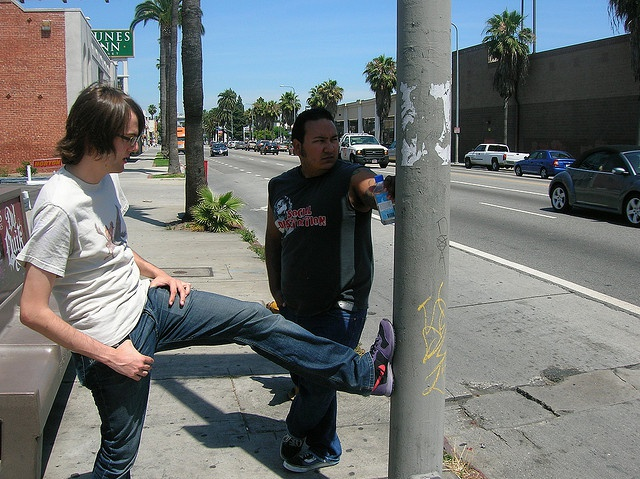Describe the objects in this image and their specific colors. I can see people in gray, black, lightgray, and darkgray tones, people in gray, black, maroon, and blue tones, bench in gray, darkgray, and black tones, car in gray, black, navy, and blue tones, and truck in gray, black, lightgray, and darkgray tones in this image. 